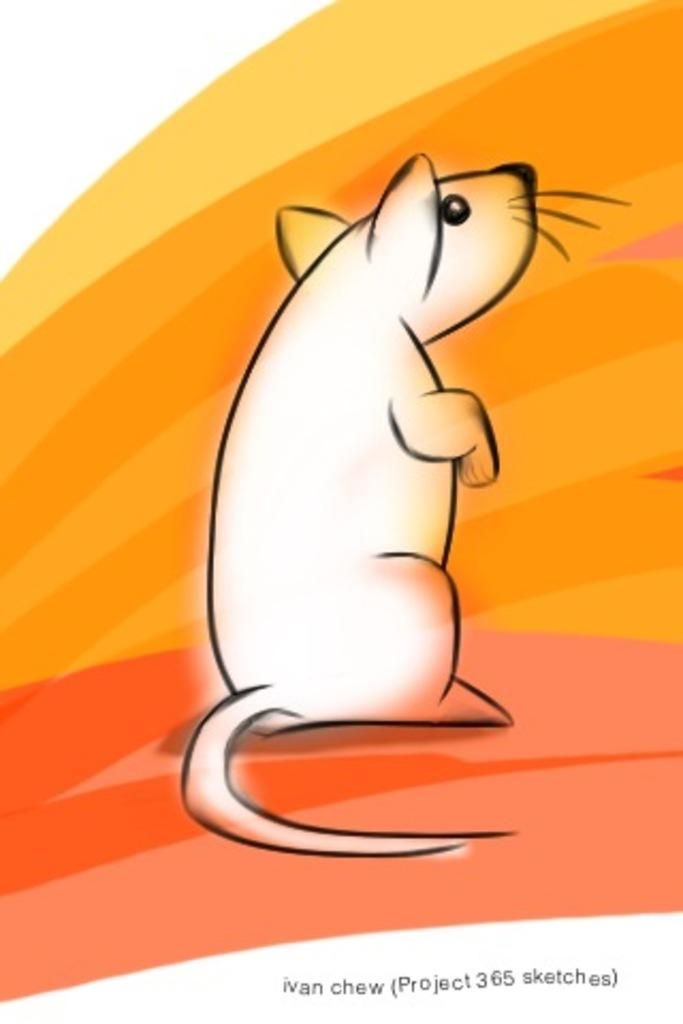What is the main subject of the image? There is a graphical image of an animal in the center of the image. What decision does the animal make in the image? There is no indication in the image that the animal is making any decisions, as it is a graphical image and not a living creature. 